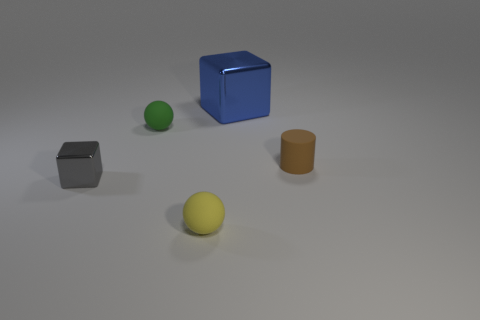Add 1 small rubber cylinders. How many objects exist? 6 Subtract all cylinders. How many objects are left? 4 Add 2 green rubber things. How many green rubber things exist? 3 Subtract 0 brown balls. How many objects are left? 5 Subtract all small gray metal cubes. Subtract all tiny shiny objects. How many objects are left? 3 Add 5 small yellow matte things. How many small yellow matte things are left? 6 